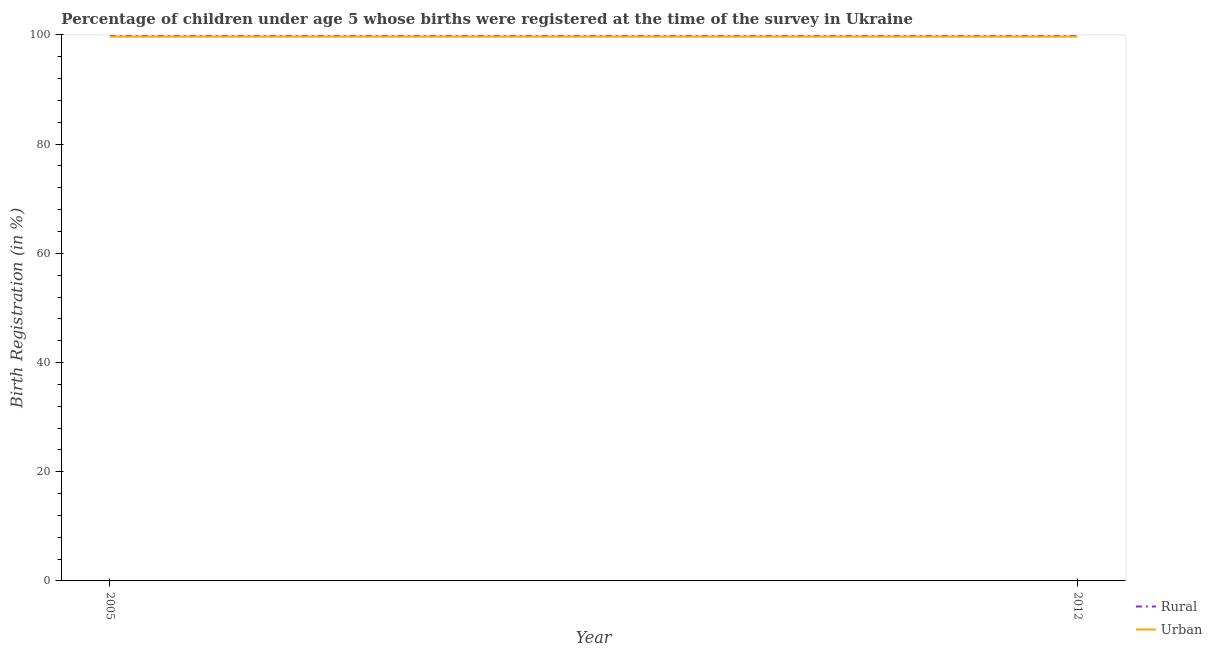How many different coloured lines are there?
Provide a short and direct response. 2. Does the line corresponding to rural birth registration intersect with the line corresponding to urban birth registration?
Make the answer very short. No. Is the number of lines equal to the number of legend labels?
Keep it short and to the point. Yes. What is the urban birth registration in 2005?
Your answer should be very brief. 99.7. Across all years, what is the maximum rural birth registration?
Your answer should be very brief. 100. Across all years, what is the minimum rural birth registration?
Your answer should be compact. 100. In which year was the rural birth registration maximum?
Provide a succinct answer. 2005. In which year was the rural birth registration minimum?
Your response must be concise. 2005. What is the total urban birth registration in the graph?
Your answer should be very brief. 199.4. What is the difference between the urban birth registration in 2012 and the rural birth registration in 2005?
Ensure brevity in your answer.  -0.3. What is the average urban birth registration per year?
Your answer should be very brief. 99.7. In the year 2012, what is the difference between the rural birth registration and urban birth registration?
Provide a succinct answer. 0.3. Is the urban birth registration in 2005 less than that in 2012?
Offer a terse response. No. Does the rural birth registration monotonically increase over the years?
Provide a succinct answer. No. Is the rural birth registration strictly greater than the urban birth registration over the years?
Provide a succinct answer. Yes. Is the urban birth registration strictly less than the rural birth registration over the years?
Provide a succinct answer. Yes. How many years are there in the graph?
Your answer should be very brief. 2. What is the difference between two consecutive major ticks on the Y-axis?
Offer a very short reply. 20. Are the values on the major ticks of Y-axis written in scientific E-notation?
Provide a succinct answer. No. Does the graph contain any zero values?
Provide a succinct answer. No. How are the legend labels stacked?
Offer a terse response. Vertical. What is the title of the graph?
Offer a terse response. Percentage of children under age 5 whose births were registered at the time of the survey in Ukraine. Does "UN agencies" appear as one of the legend labels in the graph?
Keep it short and to the point. No. What is the label or title of the X-axis?
Your answer should be compact. Year. What is the label or title of the Y-axis?
Give a very brief answer. Birth Registration (in %). What is the Birth Registration (in %) in Urban in 2005?
Ensure brevity in your answer.  99.7. What is the Birth Registration (in %) of Urban in 2012?
Give a very brief answer. 99.7. Across all years, what is the maximum Birth Registration (in %) in Urban?
Provide a short and direct response. 99.7. Across all years, what is the minimum Birth Registration (in %) of Urban?
Keep it short and to the point. 99.7. What is the total Birth Registration (in %) in Urban in the graph?
Your answer should be compact. 199.4. What is the difference between the Birth Registration (in %) in Urban in 2005 and that in 2012?
Offer a very short reply. 0. What is the difference between the Birth Registration (in %) in Rural in 2005 and the Birth Registration (in %) in Urban in 2012?
Your response must be concise. 0.3. What is the average Birth Registration (in %) in Rural per year?
Your answer should be very brief. 100. What is the average Birth Registration (in %) of Urban per year?
Offer a terse response. 99.7. What is the difference between the highest and the second highest Birth Registration (in %) in Urban?
Ensure brevity in your answer.  0. What is the difference between the highest and the lowest Birth Registration (in %) of Rural?
Provide a succinct answer. 0. 